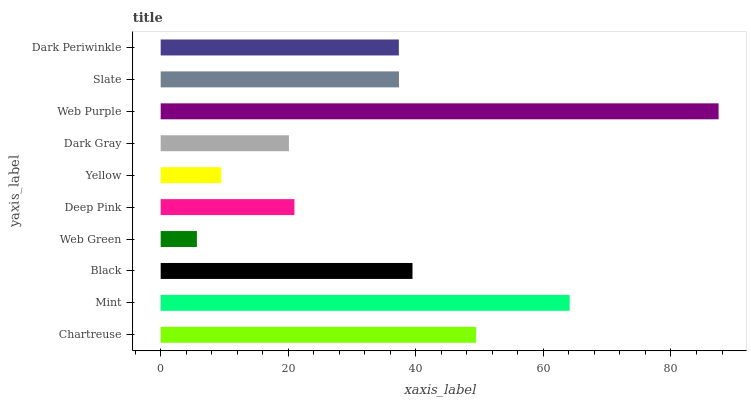Is Web Green the minimum?
Answer yes or no. Yes. Is Web Purple the maximum?
Answer yes or no. Yes. Is Mint the minimum?
Answer yes or no. No. Is Mint the maximum?
Answer yes or no. No. Is Mint greater than Chartreuse?
Answer yes or no. Yes. Is Chartreuse less than Mint?
Answer yes or no. Yes. Is Chartreuse greater than Mint?
Answer yes or no. No. Is Mint less than Chartreuse?
Answer yes or no. No. Is Slate the high median?
Answer yes or no. Yes. Is Dark Periwinkle the low median?
Answer yes or no. Yes. Is Web Green the high median?
Answer yes or no. No. Is Slate the low median?
Answer yes or no. No. 